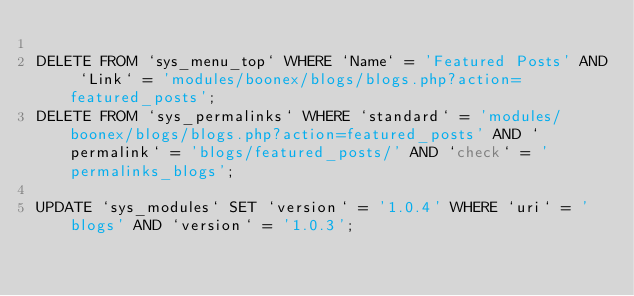<code> <loc_0><loc_0><loc_500><loc_500><_SQL_>
DELETE FROM `sys_menu_top` WHERE `Name` = 'Featured Posts' AND `Link` = 'modules/boonex/blogs/blogs.php?action=featured_posts';
DELETE FROM `sys_permalinks` WHERE `standard` = 'modules/boonex/blogs/blogs.php?action=featured_posts' AND `permalink` = 'blogs/featured_posts/' AND `check` = 'permalinks_blogs';

UPDATE `sys_modules` SET `version` = '1.0.4' WHERE `uri` = 'blogs' AND `version` = '1.0.3';

</code> 